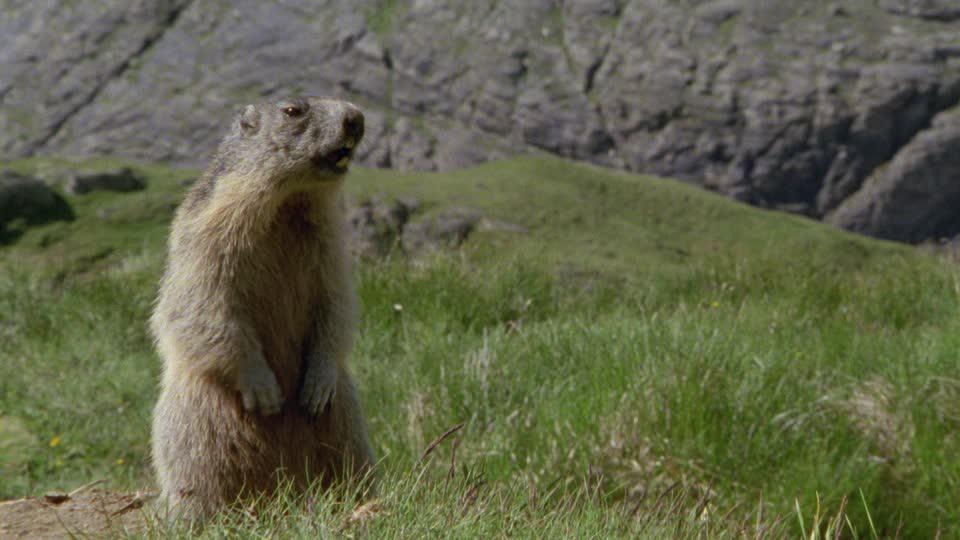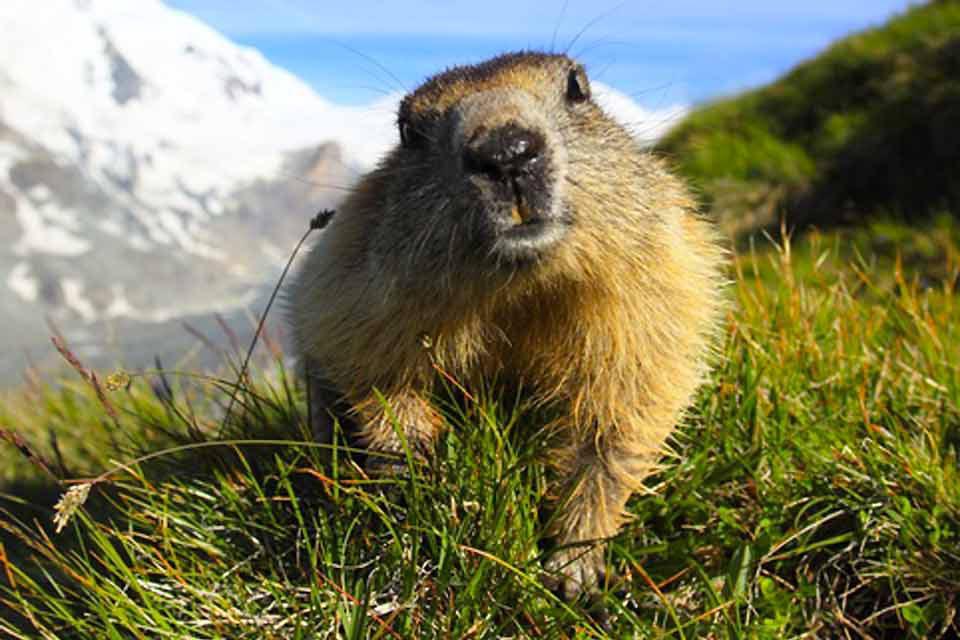The first image is the image on the left, the second image is the image on the right. Examine the images to the left and right. Is the description "There is more than one animal in at least one image." accurate? Answer yes or no. No. 